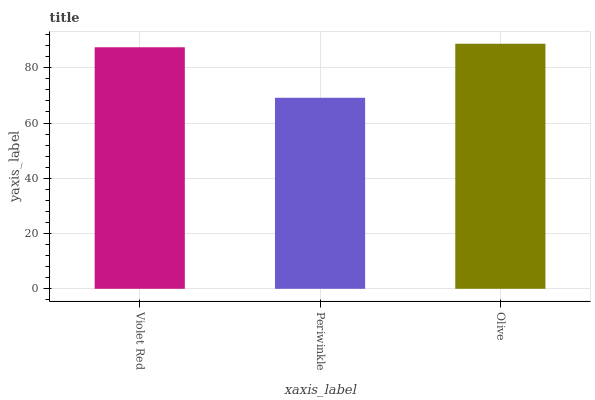Is Periwinkle the minimum?
Answer yes or no. Yes. Is Olive the maximum?
Answer yes or no. Yes. Is Olive the minimum?
Answer yes or no. No. Is Periwinkle the maximum?
Answer yes or no. No. Is Olive greater than Periwinkle?
Answer yes or no. Yes. Is Periwinkle less than Olive?
Answer yes or no. Yes. Is Periwinkle greater than Olive?
Answer yes or no. No. Is Olive less than Periwinkle?
Answer yes or no. No. Is Violet Red the high median?
Answer yes or no. Yes. Is Violet Red the low median?
Answer yes or no. Yes. Is Olive the high median?
Answer yes or no. No. Is Periwinkle the low median?
Answer yes or no. No. 